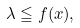<formula> <loc_0><loc_0><loc_500><loc_500>\lambda \leqq f ( x ) ,</formula> 